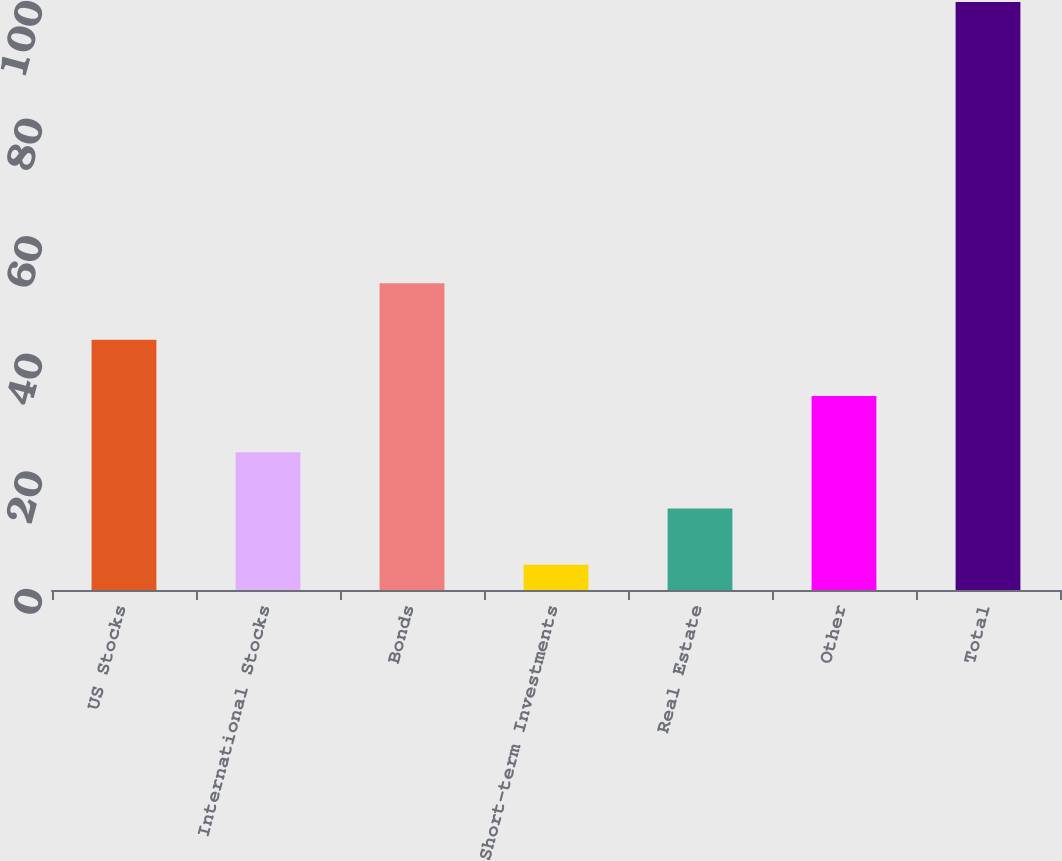<chart> <loc_0><loc_0><loc_500><loc_500><bar_chart><fcel>US Stocks<fcel>International Stocks<fcel>Bonds<fcel>Short-term Investments<fcel>Real Estate<fcel>Other<fcel>Total<nl><fcel>42.58<fcel>23.44<fcel>52.15<fcel>4.3<fcel>13.87<fcel>33.01<fcel>100<nl></chart> 